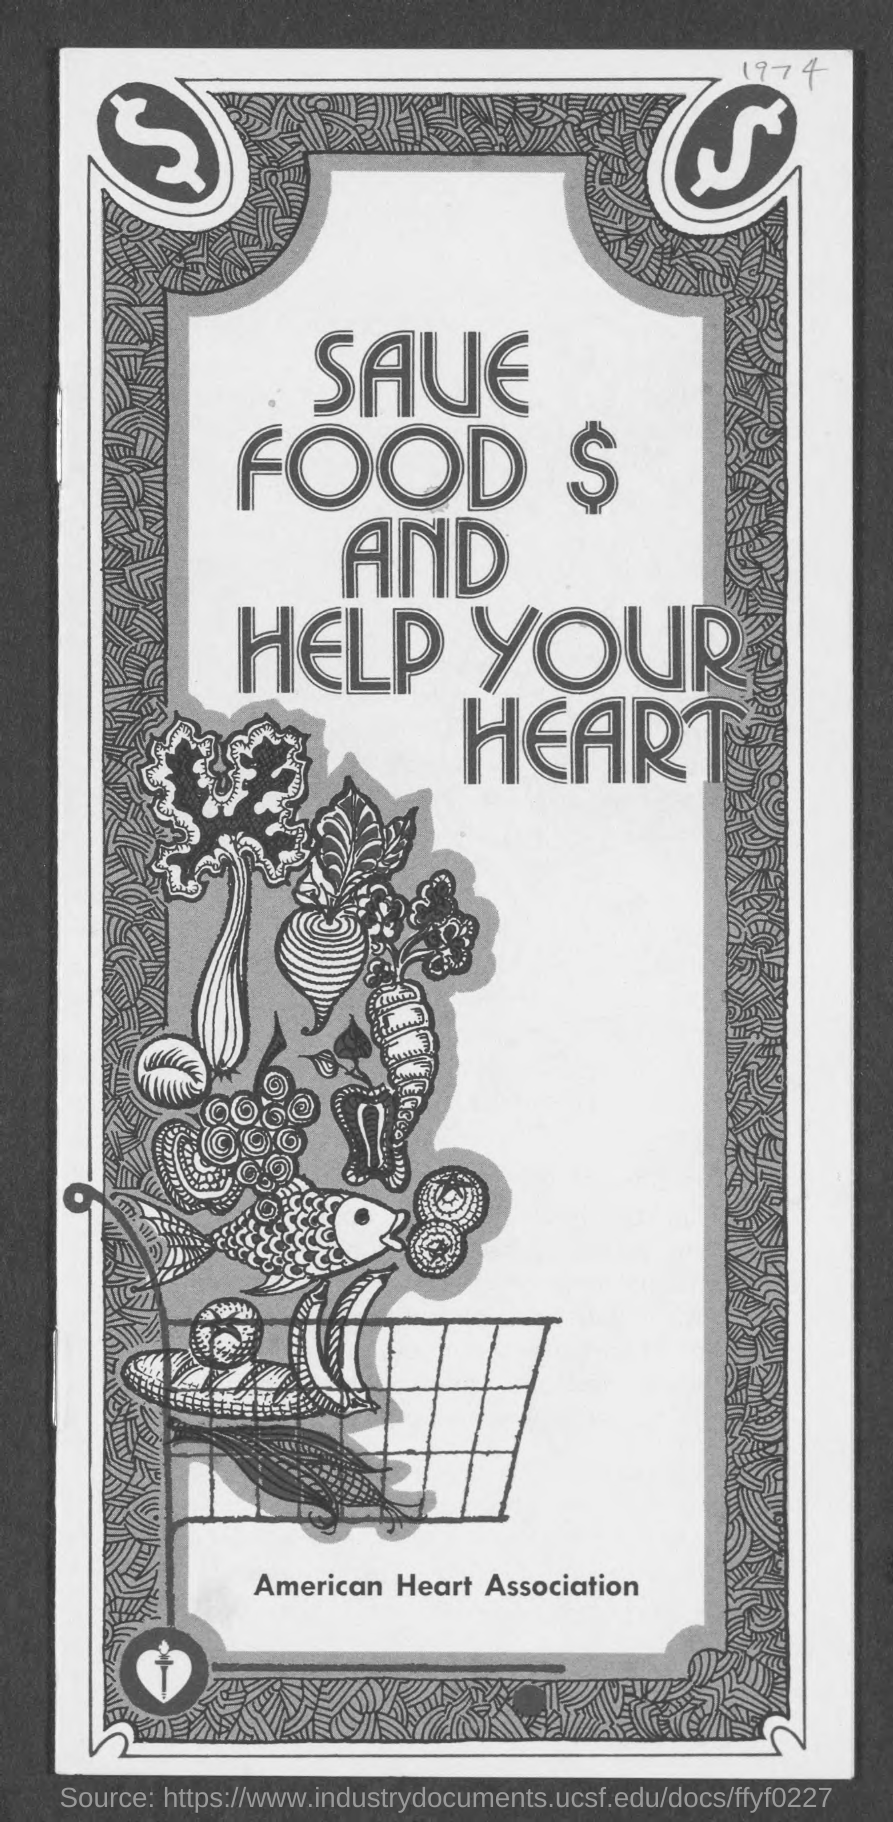What is the Year?
Offer a very short reply. 1974. Which association mentioned in this document?
Offer a terse response. American heart association. 